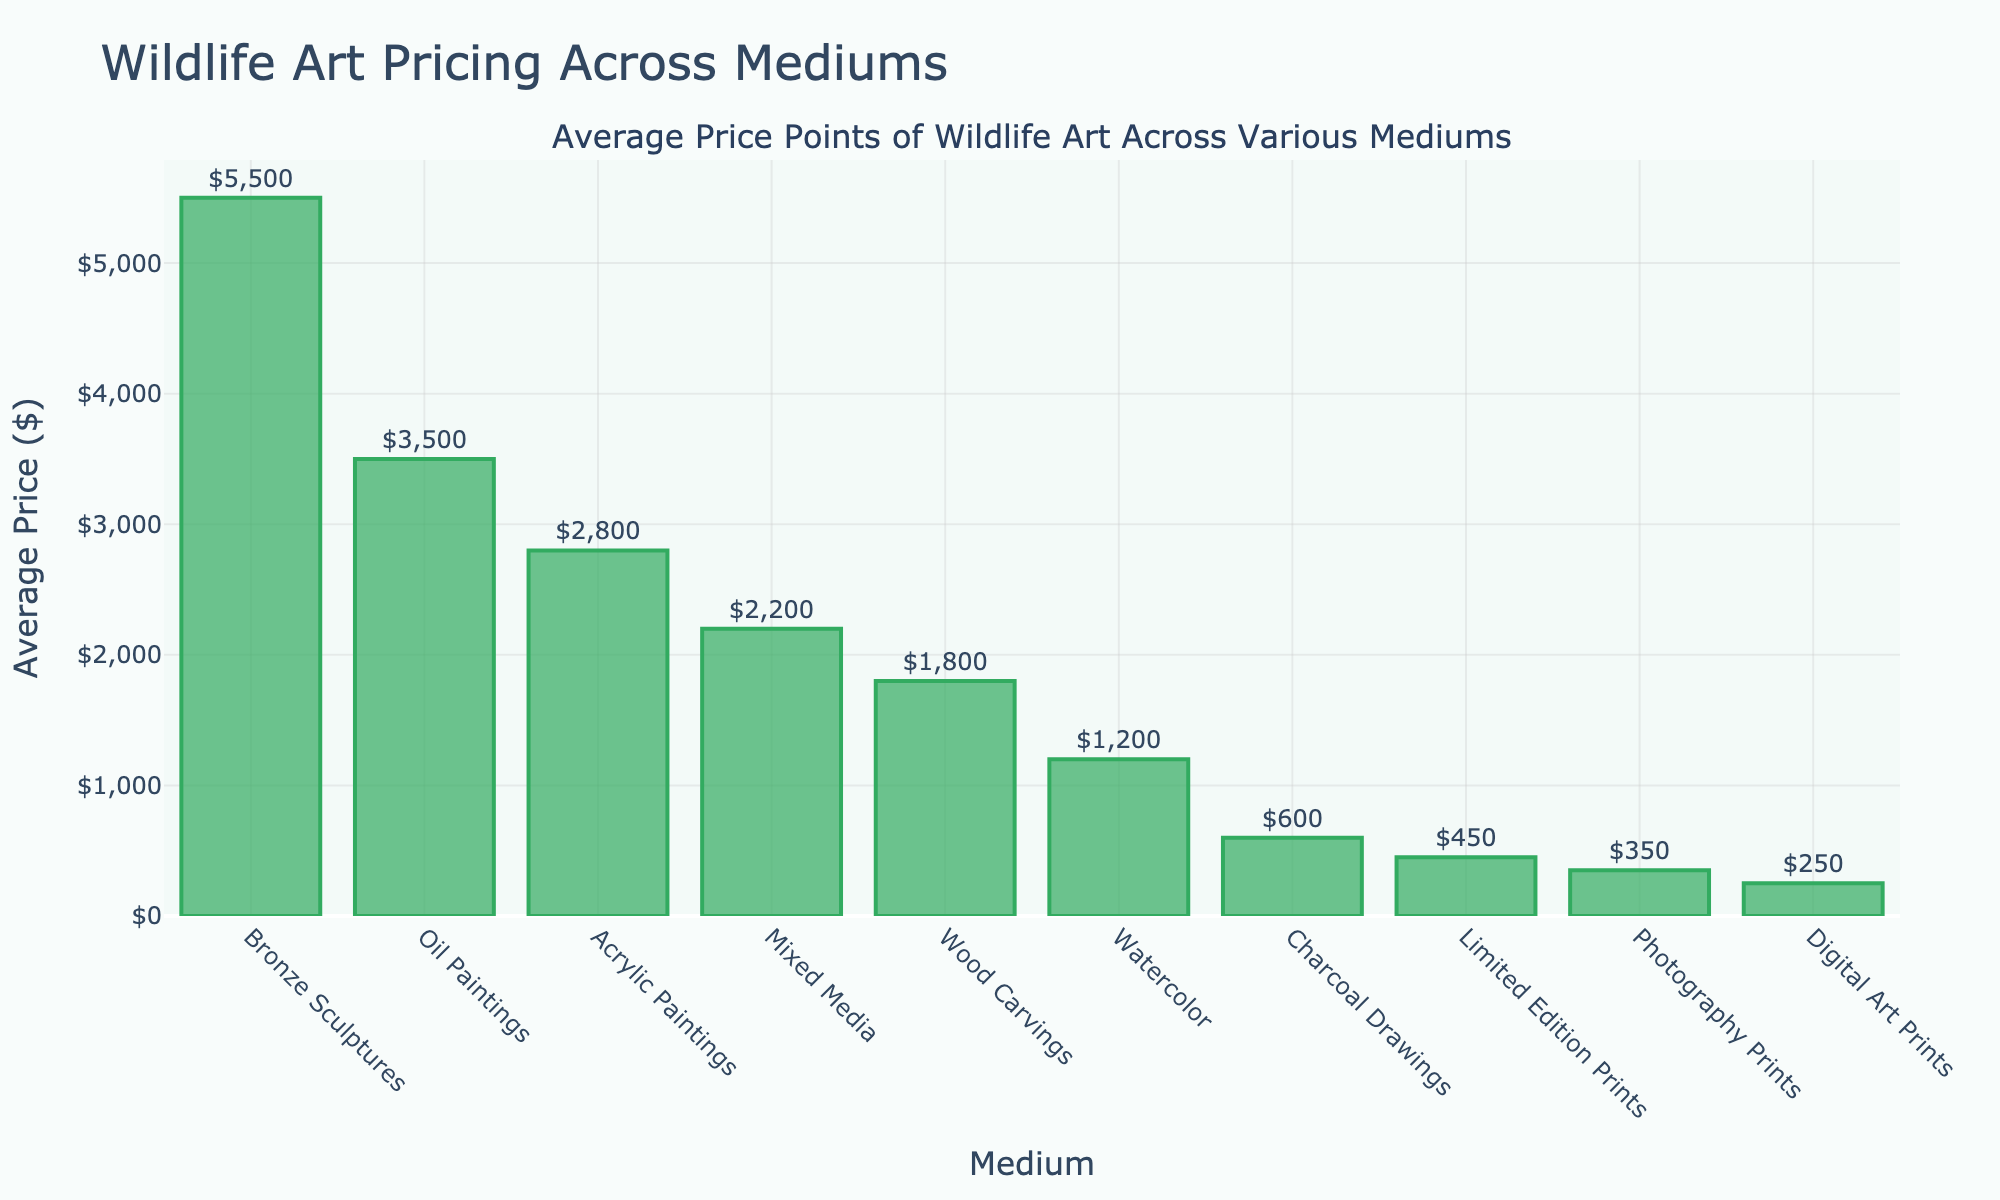Which medium has the highest average price? The medium with the highest bar represents the highest average price. In the chart, the tallest bar corresponds to Bronze Sculptures.
Answer: Bronze Sculptures What is the average price of photography prints? Locate the bar labeled "Photography Prints" and refer to its height or the value displayed above it.
Answer: $350 Which mediums have an average price above $2000? Identify bars with heights greater than $2000 or those with values displayed above showing more than $2000. These are Oil Paintings, Acrylic Paintings, and Bronze Sculptures.
Answer: Oil Paintings, Acrylic Paintings, Bronze Sculptures What is the difference in average price between Oil Paintings and Watercolor? Subtract the average price of Watercolor from that of Oil Paintings, i.e., $3500 - $1200.
Answer: $2,300 Rank the top three mediums by average price. Order the values from highest to lowest and pick the top three: Bronze Sculptures ($5500), Oil Paintings ($3500), and Acrylic Paintings ($2800).
Answer: Bronze Sculptures, Oil Paintings, Acrylic Paintings Which medium has a lower average price, Mixed Media or Digital Art Prints? Compare the heights or the values of the bars labeled "Mixed Media" and "Digital Art Prints". Mixed Media is $2200 and Digital Art Prints is $250, so Digital Art Prints is lower.
Answer: Digital Art Prints What is the combined average price of Watercolor and Charcoal Drawings? Add the average prices of Watercolor and Charcoal Drawings, i.e., $1200 + $600.
Answer: $1,800 How much higher is the average price of Wood Carvings compared to Limited Edition Prints? Subtract the average price of Limited Edition Prints from that of Wood Carvings, i.e., $1800 - $450.
Answer: $1,350 Identify the medium with the lowest average price. The shortest bar represents the lowest average price. In the chart, the shortest bar corresponds to Digital Art Prints.
Answer: Digital Art Prints 